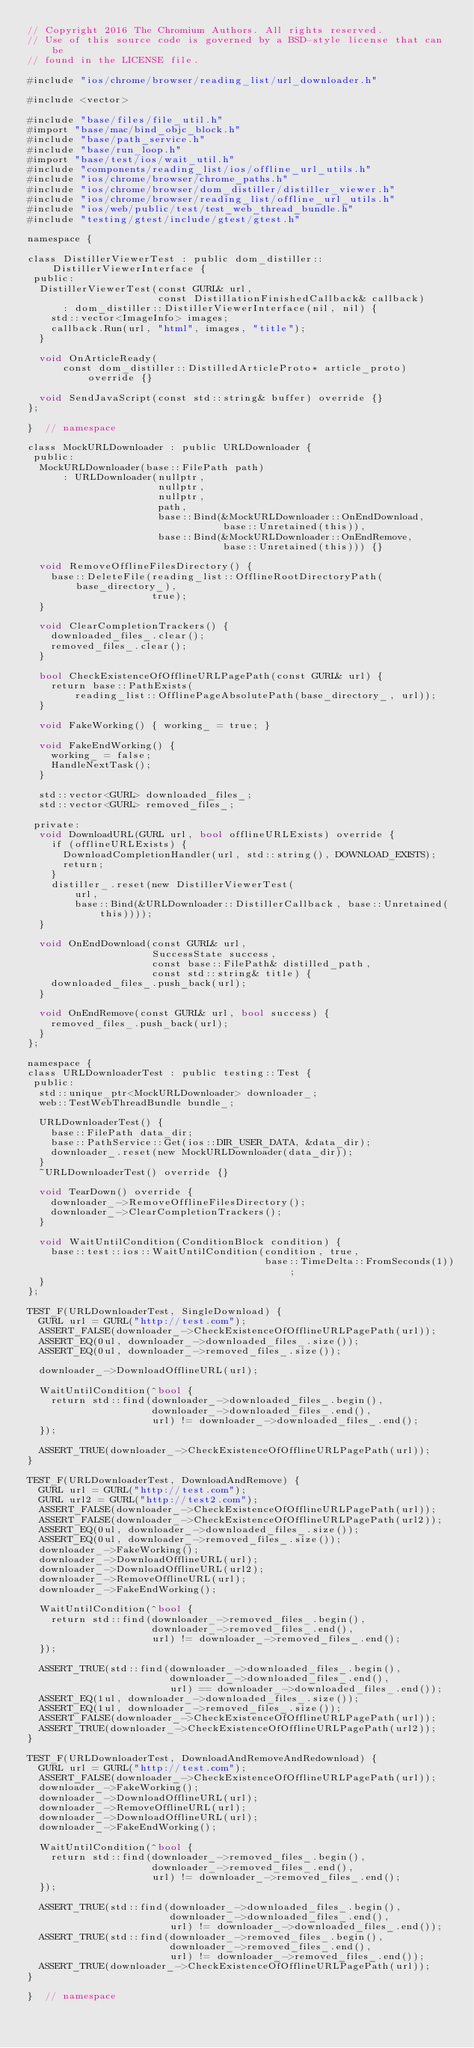<code> <loc_0><loc_0><loc_500><loc_500><_ObjectiveC_>// Copyright 2016 The Chromium Authors. All rights reserved.
// Use of this source code is governed by a BSD-style license that can be
// found in the LICENSE file.

#include "ios/chrome/browser/reading_list/url_downloader.h"

#include <vector>

#include "base/files/file_util.h"
#import "base/mac/bind_objc_block.h"
#include "base/path_service.h"
#include "base/run_loop.h"
#import "base/test/ios/wait_util.h"
#include "components/reading_list/ios/offline_url_utils.h"
#include "ios/chrome/browser/chrome_paths.h"
#include "ios/chrome/browser/dom_distiller/distiller_viewer.h"
#include "ios/chrome/browser/reading_list/offline_url_utils.h"
#include "ios/web/public/test/test_web_thread_bundle.h"
#include "testing/gtest/include/gtest/gtest.h"

namespace {

class DistillerViewerTest : public dom_distiller::DistillerViewerInterface {
 public:
  DistillerViewerTest(const GURL& url,
                      const DistillationFinishedCallback& callback)
      : dom_distiller::DistillerViewerInterface(nil, nil) {
    std::vector<ImageInfo> images;
    callback.Run(url, "html", images, "title");
  }

  void OnArticleReady(
      const dom_distiller::DistilledArticleProto* article_proto) override {}

  void SendJavaScript(const std::string& buffer) override {}
};

}  // namespace

class MockURLDownloader : public URLDownloader {
 public:
  MockURLDownloader(base::FilePath path)
      : URLDownloader(nullptr,
                      nullptr,
                      nullptr,
                      path,
                      base::Bind(&MockURLDownloader::OnEndDownload,
                                 base::Unretained(this)),
                      base::Bind(&MockURLDownloader::OnEndRemove,
                                 base::Unretained(this))) {}

  void RemoveOfflineFilesDirectory() {
    base::DeleteFile(reading_list::OfflineRootDirectoryPath(base_directory_),
                     true);
  }

  void ClearCompletionTrackers() {
    downloaded_files_.clear();
    removed_files_.clear();
  }

  bool CheckExistenceOfOfflineURLPagePath(const GURL& url) {
    return base::PathExists(
        reading_list::OfflinePageAbsolutePath(base_directory_, url));
  }

  void FakeWorking() { working_ = true; }

  void FakeEndWorking() {
    working_ = false;
    HandleNextTask();
  }

  std::vector<GURL> downloaded_files_;
  std::vector<GURL> removed_files_;

 private:
  void DownloadURL(GURL url, bool offlineURLExists) override {
    if (offlineURLExists) {
      DownloadCompletionHandler(url, std::string(), DOWNLOAD_EXISTS);
      return;
    }
    distiller_.reset(new DistillerViewerTest(
        url,
        base::Bind(&URLDownloader::DistillerCallback, base::Unretained(this))));
  }

  void OnEndDownload(const GURL& url,
                     SuccessState success,
                     const base::FilePath& distilled_path,
                     const std::string& title) {
    downloaded_files_.push_back(url);
  }

  void OnEndRemove(const GURL& url, bool success) {
    removed_files_.push_back(url);
  }
};

namespace {
class URLDownloaderTest : public testing::Test {
 public:
  std::unique_ptr<MockURLDownloader> downloader_;
  web::TestWebThreadBundle bundle_;

  URLDownloaderTest() {
    base::FilePath data_dir;
    base::PathService::Get(ios::DIR_USER_DATA, &data_dir);
    downloader_.reset(new MockURLDownloader(data_dir));
  }
  ~URLDownloaderTest() override {}

  void TearDown() override {
    downloader_->RemoveOfflineFilesDirectory();
    downloader_->ClearCompletionTrackers();
  }

  void WaitUntilCondition(ConditionBlock condition) {
    base::test::ios::WaitUntilCondition(condition, true,
                                        base::TimeDelta::FromSeconds(1));
  }
};

TEST_F(URLDownloaderTest, SingleDownload) {
  GURL url = GURL("http://test.com");
  ASSERT_FALSE(downloader_->CheckExistenceOfOfflineURLPagePath(url));
  ASSERT_EQ(0ul, downloader_->downloaded_files_.size());
  ASSERT_EQ(0ul, downloader_->removed_files_.size());

  downloader_->DownloadOfflineURL(url);

  WaitUntilCondition(^bool {
    return std::find(downloader_->downloaded_files_.begin(),
                     downloader_->downloaded_files_.end(),
                     url) != downloader_->downloaded_files_.end();
  });

  ASSERT_TRUE(downloader_->CheckExistenceOfOfflineURLPagePath(url));
}

TEST_F(URLDownloaderTest, DownloadAndRemove) {
  GURL url = GURL("http://test.com");
  GURL url2 = GURL("http://test2.com");
  ASSERT_FALSE(downloader_->CheckExistenceOfOfflineURLPagePath(url));
  ASSERT_FALSE(downloader_->CheckExistenceOfOfflineURLPagePath(url2));
  ASSERT_EQ(0ul, downloader_->downloaded_files_.size());
  ASSERT_EQ(0ul, downloader_->removed_files_.size());
  downloader_->FakeWorking();
  downloader_->DownloadOfflineURL(url);
  downloader_->DownloadOfflineURL(url2);
  downloader_->RemoveOfflineURL(url);
  downloader_->FakeEndWorking();

  WaitUntilCondition(^bool {
    return std::find(downloader_->removed_files_.begin(),
                     downloader_->removed_files_.end(),
                     url) != downloader_->removed_files_.end();
  });

  ASSERT_TRUE(std::find(downloader_->downloaded_files_.begin(),
                        downloader_->downloaded_files_.end(),
                        url) == downloader_->downloaded_files_.end());
  ASSERT_EQ(1ul, downloader_->downloaded_files_.size());
  ASSERT_EQ(1ul, downloader_->removed_files_.size());
  ASSERT_FALSE(downloader_->CheckExistenceOfOfflineURLPagePath(url));
  ASSERT_TRUE(downloader_->CheckExistenceOfOfflineURLPagePath(url2));
}

TEST_F(URLDownloaderTest, DownloadAndRemoveAndRedownload) {
  GURL url = GURL("http://test.com");
  ASSERT_FALSE(downloader_->CheckExistenceOfOfflineURLPagePath(url));
  downloader_->FakeWorking();
  downloader_->DownloadOfflineURL(url);
  downloader_->RemoveOfflineURL(url);
  downloader_->DownloadOfflineURL(url);
  downloader_->FakeEndWorking();

  WaitUntilCondition(^bool {
    return std::find(downloader_->removed_files_.begin(),
                     downloader_->removed_files_.end(),
                     url) != downloader_->removed_files_.end();
  });

  ASSERT_TRUE(std::find(downloader_->downloaded_files_.begin(),
                        downloader_->downloaded_files_.end(),
                        url) != downloader_->downloaded_files_.end());
  ASSERT_TRUE(std::find(downloader_->removed_files_.begin(),
                        downloader_->removed_files_.end(),
                        url) != downloader_->removed_files_.end());
  ASSERT_TRUE(downloader_->CheckExistenceOfOfflineURLPagePath(url));
}

}  // namespace
</code> 